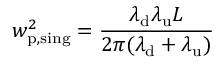<formula> <loc_0><loc_0><loc_500><loc_500>w _ { p , \sin g } ^ { 2 } = \frac { \lambda _ { d } \lambda _ { u } L } { 2 \pi ( \lambda _ { d } + \lambda _ { u } ) }</formula> 